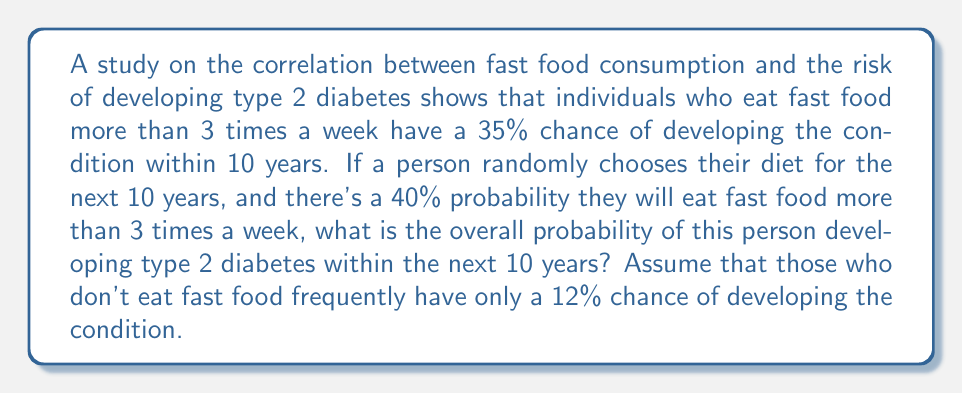Can you answer this question? Let's approach this step-by-step using the law of total probability:

1) Define events:
   A: Developing type 2 diabetes within 10 years
   B: Eating fast food more than 3 times a week
   
2) Given probabilities:
   $P(B) = 0.40$ (probability of eating fast food frequently)
   $P(A|B) = 0.35$ (probability of diabetes given frequent fast food)
   $P(A|\text{not }B) = 0.12$ (probability of diabetes given infrequent fast food)

3) Law of Total Probability:
   $P(A) = P(A|B) \cdot P(B) + P(A|\text{not }B) \cdot P(\text{not }B)$

4) Calculate $P(\text{not }B)$:
   $P(\text{not }B) = 1 - P(B) = 1 - 0.40 = 0.60$

5) Substitute values into the formula:
   $P(A) = 0.35 \cdot 0.40 + 0.12 \cdot 0.60$

6) Calculate:
   $P(A) = 0.14 + 0.072 = 0.212$

Therefore, the overall probability of developing type 2 diabetes within 10 years is 0.212 or 21.2%.
Answer: 0.212 or 21.2% 